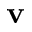Convert formula to latex. <formula><loc_0><loc_0><loc_500><loc_500>v</formula> 